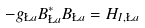Convert formula to latex. <formula><loc_0><loc_0><loc_500><loc_500>- g _ { \L a } B ^ { * } _ { \L a } B _ { \L a } = H _ { I , \L a }</formula> 